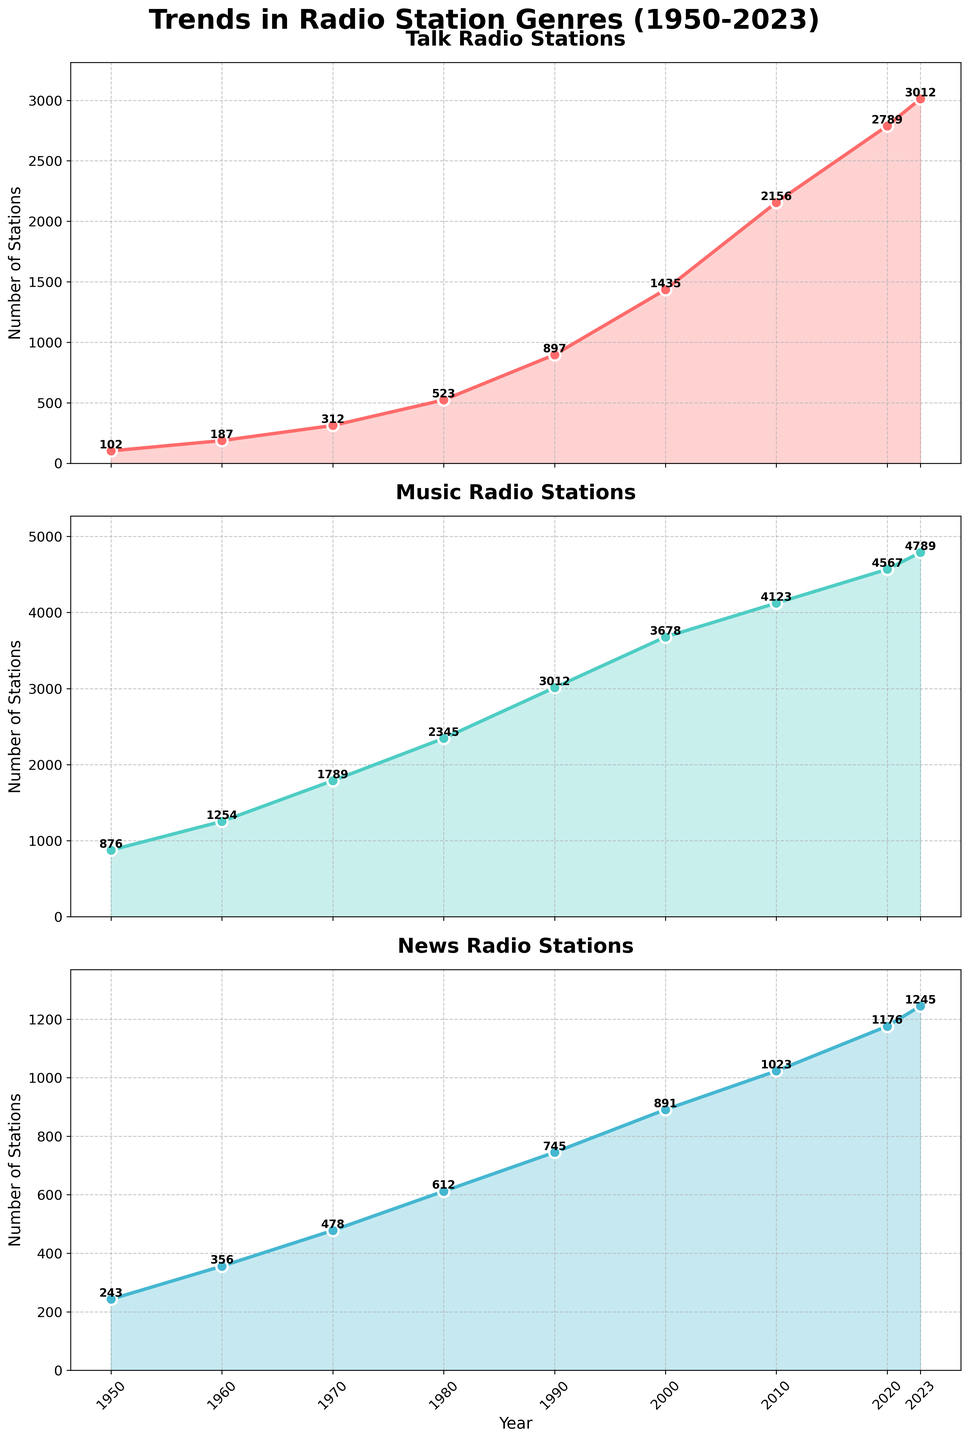what are the genres of radio stations shown in the figure? The genres are listed in the legend or title of the subplots. According to the data, the genres include "Talk Radio," "Music Radio," and "News Radio."
Answer: Talk Radio, Music Radio, News Radio how many years are presented in the figure? The x-axis shows the range of years covered in the figure. The plot includes data from 1950 to 2023, spanning 9 different years.
Answer: 9 which genre had the highest number of radio stations in 1980? By examining the y-axis values for each subplot, we can determine that "Music Radio" had around 2345 stations in 1980, which is higher than both "Talk Radio" and "News Radio."
Answer: Music Radio in which year did talk radio surpass 2000 stations? The y-axis values for "Talk Radio" subplots show the number of stations by year. "Talk Radio" reached 2156 stations in 2010, surpassing the 2000 station mark.
Answer: 2010 what is the difference in the number of music radio stations between 1960 and 2023? First, identify the number of Music Radio stations in both years: 1254 in 1960 and 4789 in 2023. Calculate the difference: 4789 - 1254 = 3535.
Answer: 3535 which genre had the steepest increase between 1950 and 2000, and what was the increase? By looking at the growth in each subplot, "Talk Radio" increased from 102 in 1950 to 1435 in 2000, an increase of 1333. "Music Radio" increased from 876 to 3678, an increase of 2802. "News Radio" increased from 243 to 891, a difference of 648. The steepest increase was in "Music Radio," with an increase of 2802 stations.
Answer: Music Radio, 2802 did any genre of radio stations initially have fewer than 500 stations but exceed 2000 stations by 2023? Starting with fewer than 500 stations in 1950, "Talk Radio" had only 102. By 2023, it had increased to 3012, which exceeds 2000 stations.
Answer: Talk Radio what is the general trend observed for news radio stations from 1950 to 2023? The "News Radio" subplot shows a steady increase over the years. Starting at 243 stations in 1950, it grew to 1245 stations by 2023.
Answer: Steady increase 